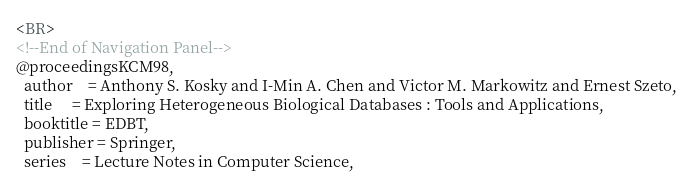<code> <loc_0><loc_0><loc_500><loc_500><_HTML_><BR>
<!--End of Navigation Panel-->
@proceedingsKCM98,
  author    = Anthony S. Kosky and I-Min A. Chen and Victor M. Markowitz and Ernest Szeto,
  title     = Exploring Heterogeneous Biological Databases : Tools and Applications,
  booktitle = EDBT,
  publisher = Springer,
  series    = Lecture Notes in Computer Science,</code> 